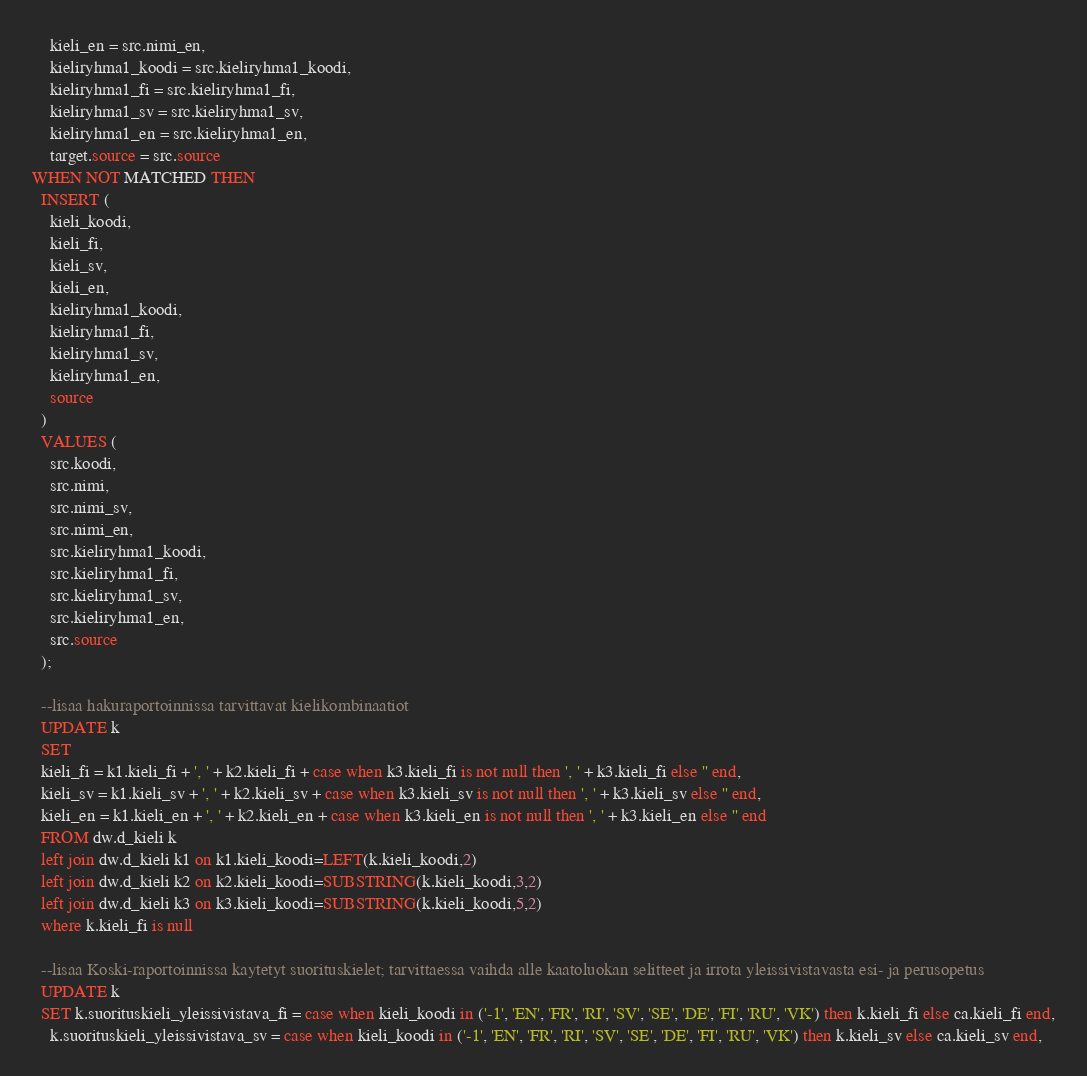<code> <loc_0><loc_0><loc_500><loc_500><_SQL_>    kieli_en = src.nimi_en,
	kieliryhma1_koodi = src.kieliryhma1_koodi,
	kieliryhma1_fi = src.kieliryhma1_fi,
	kieliryhma1_sv = src.kieliryhma1_sv,
	kieliryhma1_en = src.kieliryhma1_en,
    target.source = src.source
WHEN NOT MATCHED THEN
  INSERT (
    kieli_koodi,
    kieli_fi,
    kieli_sv,
    kieli_en,
	kieliryhma1_koodi,
	kieliryhma1_fi,
	kieliryhma1_sv,
	kieliryhma1_en,
    source
  )
  VALUES (
    src.koodi, 
	src.nimi, 
	src.nimi_sv, 
	src.nimi_en,
	src.kieliryhma1_koodi,
	src.kieliryhma1_fi,
	src.kieliryhma1_sv,
	src.kieliryhma1_en,
    src.source
  );

  --lisaa hakuraportoinnissa tarvittavat kielikombinaatiot
  UPDATE k
  SET 
  kieli_fi = k1.kieli_fi + ', ' + k2.kieli_fi + case when k3.kieli_fi is not null then ', ' + k3.kieli_fi else '' end,
  kieli_sv = k1.kieli_sv + ', ' + k2.kieli_sv + case when k3.kieli_sv is not null then ', ' + k3.kieli_sv else '' end,
  kieli_en = k1.kieli_en + ', ' + k2.kieli_en + case when k3.kieli_en is not null then ', ' + k3.kieli_en else '' end
  FROM dw.d_kieli k
  left join dw.d_kieli k1 on k1.kieli_koodi=LEFT(k.kieli_koodi,2)
  left join dw.d_kieli k2 on k2.kieli_koodi=SUBSTRING(k.kieli_koodi,3,2)
  left join dw.d_kieli k3 on k3.kieli_koodi=SUBSTRING(k.kieli_koodi,5,2)
  where k.kieli_fi is null

  --lisaa Koski-raportoinnissa kaytetyt suorituskielet; tarvittaessa vaihda alle kaatoluokan selitteet ja irrota yleissivistavasta esi- ja perusopetus
  UPDATE k
  SET k.suorituskieli_yleissivistava_fi = case when kieli_koodi in ('-1', 'EN', 'FR', 'RI', 'SV', 'SE', 'DE', 'FI', 'RU', 'VK') then k.kieli_fi else ca.kieli_fi end,
    k.suorituskieli_yleissivistava_sv = case when kieli_koodi in ('-1', 'EN', 'FR', 'RI', 'SV', 'SE', 'DE', 'FI', 'RU', 'VK') then k.kieli_sv else ca.kieli_sv end,</code> 